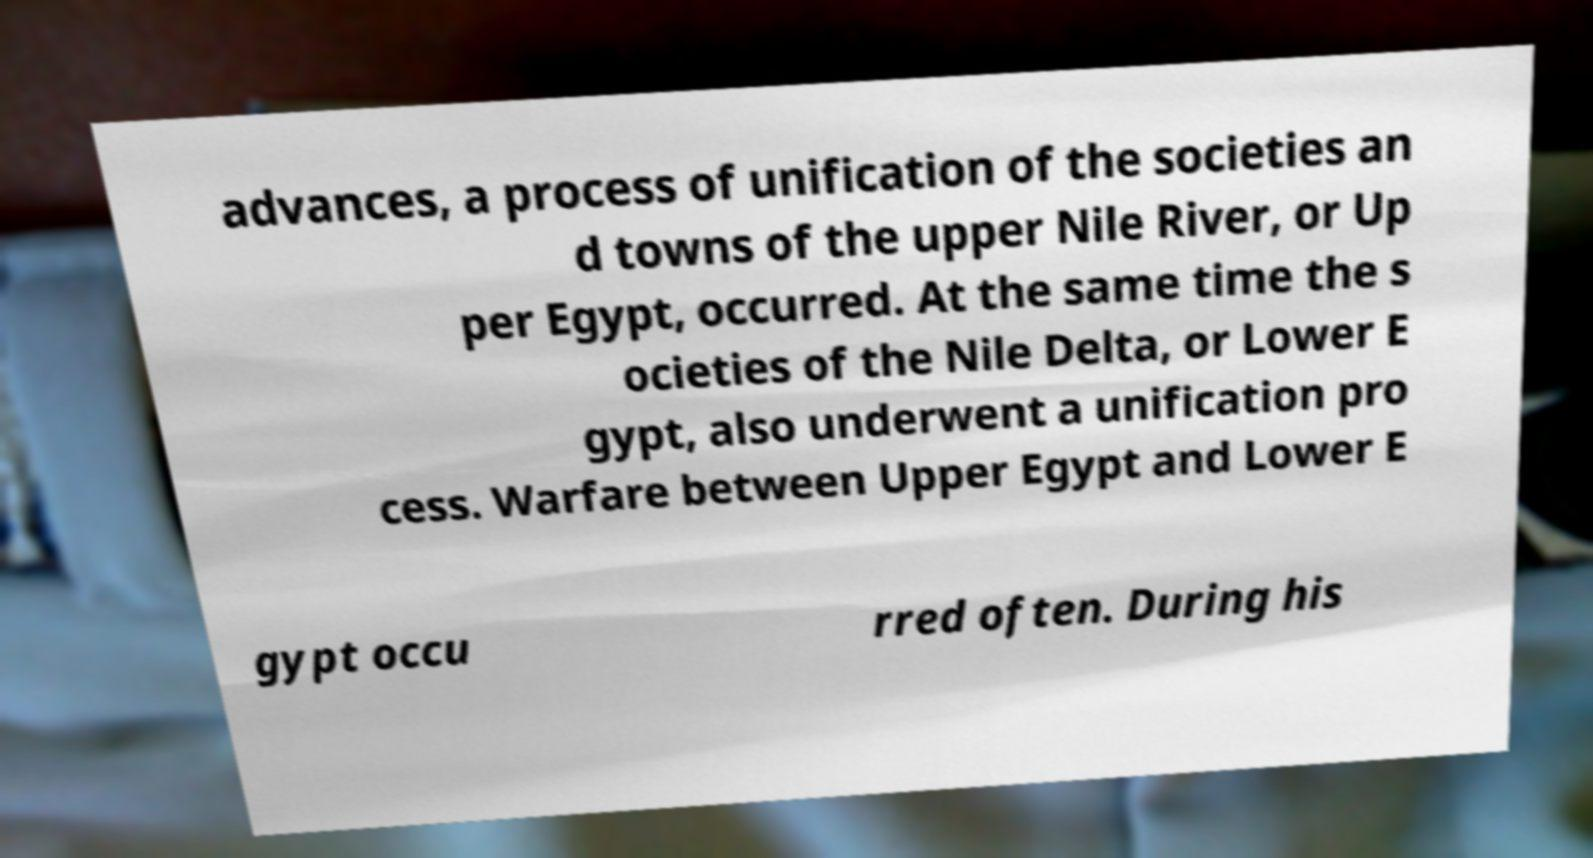Can you read and provide the text displayed in the image?This photo seems to have some interesting text. Can you extract and type it out for me? advances, a process of unification of the societies an d towns of the upper Nile River, or Up per Egypt, occurred. At the same time the s ocieties of the Nile Delta, or Lower E gypt, also underwent a unification pro cess. Warfare between Upper Egypt and Lower E gypt occu rred often. During his 